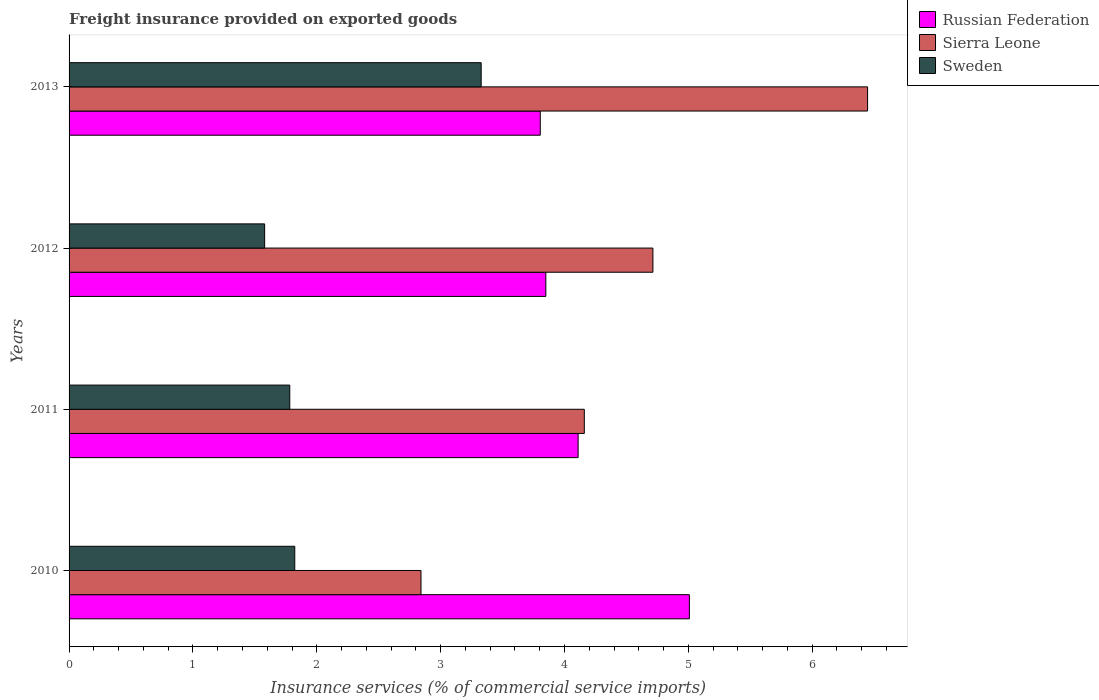How many different coloured bars are there?
Provide a succinct answer. 3. Are the number of bars per tick equal to the number of legend labels?
Provide a succinct answer. Yes. How many bars are there on the 4th tick from the top?
Offer a terse response. 3. In how many cases, is the number of bars for a given year not equal to the number of legend labels?
Ensure brevity in your answer.  0. What is the freight insurance provided on exported goods in Sweden in 2012?
Keep it short and to the point. 1.58. Across all years, what is the maximum freight insurance provided on exported goods in Sweden?
Offer a terse response. 3.33. Across all years, what is the minimum freight insurance provided on exported goods in Russian Federation?
Provide a short and direct response. 3.8. In which year was the freight insurance provided on exported goods in Sierra Leone maximum?
Offer a very short reply. 2013. What is the total freight insurance provided on exported goods in Sweden in the graph?
Provide a succinct answer. 8.51. What is the difference between the freight insurance provided on exported goods in Sweden in 2012 and that in 2013?
Ensure brevity in your answer.  -1.75. What is the difference between the freight insurance provided on exported goods in Russian Federation in 2011 and the freight insurance provided on exported goods in Sweden in 2013?
Make the answer very short. 0.78. What is the average freight insurance provided on exported goods in Sweden per year?
Keep it short and to the point. 2.13. In the year 2012, what is the difference between the freight insurance provided on exported goods in Sierra Leone and freight insurance provided on exported goods in Sweden?
Provide a short and direct response. 3.13. What is the ratio of the freight insurance provided on exported goods in Sweden in 2010 to that in 2013?
Give a very brief answer. 0.55. Is the freight insurance provided on exported goods in Russian Federation in 2010 less than that in 2012?
Keep it short and to the point. No. What is the difference between the highest and the second highest freight insurance provided on exported goods in Sierra Leone?
Give a very brief answer. 1.73. What is the difference between the highest and the lowest freight insurance provided on exported goods in Sierra Leone?
Offer a very short reply. 3.61. Is the sum of the freight insurance provided on exported goods in Russian Federation in 2011 and 2012 greater than the maximum freight insurance provided on exported goods in Sweden across all years?
Provide a short and direct response. Yes. What does the 2nd bar from the top in 2013 represents?
Give a very brief answer. Sierra Leone. What does the 2nd bar from the bottom in 2010 represents?
Your answer should be very brief. Sierra Leone. How many bars are there?
Your answer should be very brief. 12. Are all the bars in the graph horizontal?
Offer a terse response. Yes. Does the graph contain grids?
Offer a terse response. No. What is the title of the graph?
Your response must be concise. Freight insurance provided on exported goods. What is the label or title of the X-axis?
Offer a very short reply. Insurance services (% of commercial service imports). What is the label or title of the Y-axis?
Make the answer very short. Years. What is the Insurance services (% of commercial service imports) in Russian Federation in 2010?
Your answer should be very brief. 5.01. What is the Insurance services (% of commercial service imports) of Sierra Leone in 2010?
Your answer should be very brief. 2.84. What is the Insurance services (% of commercial service imports) in Sweden in 2010?
Your answer should be very brief. 1.82. What is the Insurance services (% of commercial service imports) in Russian Federation in 2011?
Offer a very short reply. 4.11. What is the Insurance services (% of commercial service imports) of Sierra Leone in 2011?
Ensure brevity in your answer.  4.16. What is the Insurance services (% of commercial service imports) in Sweden in 2011?
Provide a succinct answer. 1.78. What is the Insurance services (% of commercial service imports) in Russian Federation in 2012?
Offer a very short reply. 3.85. What is the Insurance services (% of commercial service imports) in Sierra Leone in 2012?
Make the answer very short. 4.71. What is the Insurance services (% of commercial service imports) of Sweden in 2012?
Keep it short and to the point. 1.58. What is the Insurance services (% of commercial service imports) of Russian Federation in 2013?
Your response must be concise. 3.8. What is the Insurance services (% of commercial service imports) in Sierra Leone in 2013?
Ensure brevity in your answer.  6.45. What is the Insurance services (% of commercial service imports) in Sweden in 2013?
Your answer should be compact. 3.33. Across all years, what is the maximum Insurance services (% of commercial service imports) of Russian Federation?
Offer a very short reply. 5.01. Across all years, what is the maximum Insurance services (% of commercial service imports) of Sierra Leone?
Offer a very short reply. 6.45. Across all years, what is the maximum Insurance services (% of commercial service imports) in Sweden?
Give a very brief answer. 3.33. Across all years, what is the minimum Insurance services (% of commercial service imports) of Russian Federation?
Ensure brevity in your answer.  3.8. Across all years, what is the minimum Insurance services (% of commercial service imports) in Sierra Leone?
Your answer should be very brief. 2.84. Across all years, what is the minimum Insurance services (% of commercial service imports) in Sweden?
Make the answer very short. 1.58. What is the total Insurance services (% of commercial service imports) of Russian Federation in the graph?
Provide a succinct answer. 16.77. What is the total Insurance services (% of commercial service imports) in Sierra Leone in the graph?
Make the answer very short. 18.16. What is the total Insurance services (% of commercial service imports) of Sweden in the graph?
Give a very brief answer. 8.51. What is the difference between the Insurance services (% of commercial service imports) in Russian Federation in 2010 and that in 2011?
Keep it short and to the point. 0.9. What is the difference between the Insurance services (% of commercial service imports) of Sierra Leone in 2010 and that in 2011?
Make the answer very short. -1.32. What is the difference between the Insurance services (% of commercial service imports) of Sweden in 2010 and that in 2011?
Give a very brief answer. 0.04. What is the difference between the Insurance services (% of commercial service imports) in Russian Federation in 2010 and that in 2012?
Your answer should be very brief. 1.16. What is the difference between the Insurance services (% of commercial service imports) in Sierra Leone in 2010 and that in 2012?
Your answer should be compact. -1.87. What is the difference between the Insurance services (% of commercial service imports) in Sweden in 2010 and that in 2012?
Give a very brief answer. 0.24. What is the difference between the Insurance services (% of commercial service imports) of Russian Federation in 2010 and that in 2013?
Offer a terse response. 1.2. What is the difference between the Insurance services (% of commercial service imports) in Sierra Leone in 2010 and that in 2013?
Ensure brevity in your answer.  -3.61. What is the difference between the Insurance services (% of commercial service imports) of Sweden in 2010 and that in 2013?
Offer a terse response. -1.51. What is the difference between the Insurance services (% of commercial service imports) of Russian Federation in 2011 and that in 2012?
Provide a short and direct response. 0.26. What is the difference between the Insurance services (% of commercial service imports) in Sierra Leone in 2011 and that in 2012?
Make the answer very short. -0.55. What is the difference between the Insurance services (% of commercial service imports) in Sweden in 2011 and that in 2012?
Your answer should be compact. 0.2. What is the difference between the Insurance services (% of commercial service imports) in Russian Federation in 2011 and that in 2013?
Make the answer very short. 0.31. What is the difference between the Insurance services (% of commercial service imports) in Sierra Leone in 2011 and that in 2013?
Your answer should be compact. -2.29. What is the difference between the Insurance services (% of commercial service imports) of Sweden in 2011 and that in 2013?
Your answer should be very brief. -1.55. What is the difference between the Insurance services (% of commercial service imports) of Russian Federation in 2012 and that in 2013?
Offer a terse response. 0.04. What is the difference between the Insurance services (% of commercial service imports) in Sierra Leone in 2012 and that in 2013?
Ensure brevity in your answer.  -1.73. What is the difference between the Insurance services (% of commercial service imports) of Sweden in 2012 and that in 2013?
Give a very brief answer. -1.75. What is the difference between the Insurance services (% of commercial service imports) in Russian Federation in 2010 and the Insurance services (% of commercial service imports) in Sierra Leone in 2011?
Offer a terse response. 0.85. What is the difference between the Insurance services (% of commercial service imports) of Russian Federation in 2010 and the Insurance services (% of commercial service imports) of Sweden in 2011?
Offer a very short reply. 3.23. What is the difference between the Insurance services (% of commercial service imports) in Sierra Leone in 2010 and the Insurance services (% of commercial service imports) in Sweden in 2011?
Your response must be concise. 1.06. What is the difference between the Insurance services (% of commercial service imports) in Russian Federation in 2010 and the Insurance services (% of commercial service imports) in Sierra Leone in 2012?
Provide a succinct answer. 0.29. What is the difference between the Insurance services (% of commercial service imports) in Russian Federation in 2010 and the Insurance services (% of commercial service imports) in Sweden in 2012?
Keep it short and to the point. 3.43. What is the difference between the Insurance services (% of commercial service imports) of Sierra Leone in 2010 and the Insurance services (% of commercial service imports) of Sweden in 2012?
Your response must be concise. 1.26. What is the difference between the Insurance services (% of commercial service imports) of Russian Federation in 2010 and the Insurance services (% of commercial service imports) of Sierra Leone in 2013?
Offer a very short reply. -1.44. What is the difference between the Insurance services (% of commercial service imports) of Russian Federation in 2010 and the Insurance services (% of commercial service imports) of Sweden in 2013?
Offer a very short reply. 1.68. What is the difference between the Insurance services (% of commercial service imports) of Sierra Leone in 2010 and the Insurance services (% of commercial service imports) of Sweden in 2013?
Ensure brevity in your answer.  -0.49. What is the difference between the Insurance services (% of commercial service imports) of Russian Federation in 2011 and the Insurance services (% of commercial service imports) of Sierra Leone in 2012?
Provide a short and direct response. -0.6. What is the difference between the Insurance services (% of commercial service imports) of Russian Federation in 2011 and the Insurance services (% of commercial service imports) of Sweden in 2012?
Make the answer very short. 2.53. What is the difference between the Insurance services (% of commercial service imports) of Sierra Leone in 2011 and the Insurance services (% of commercial service imports) of Sweden in 2012?
Provide a short and direct response. 2.58. What is the difference between the Insurance services (% of commercial service imports) of Russian Federation in 2011 and the Insurance services (% of commercial service imports) of Sierra Leone in 2013?
Keep it short and to the point. -2.34. What is the difference between the Insurance services (% of commercial service imports) of Russian Federation in 2011 and the Insurance services (% of commercial service imports) of Sweden in 2013?
Provide a short and direct response. 0.78. What is the difference between the Insurance services (% of commercial service imports) of Sierra Leone in 2011 and the Insurance services (% of commercial service imports) of Sweden in 2013?
Provide a short and direct response. 0.83. What is the difference between the Insurance services (% of commercial service imports) of Russian Federation in 2012 and the Insurance services (% of commercial service imports) of Sierra Leone in 2013?
Give a very brief answer. -2.6. What is the difference between the Insurance services (% of commercial service imports) in Russian Federation in 2012 and the Insurance services (% of commercial service imports) in Sweden in 2013?
Your answer should be very brief. 0.52. What is the difference between the Insurance services (% of commercial service imports) in Sierra Leone in 2012 and the Insurance services (% of commercial service imports) in Sweden in 2013?
Offer a very short reply. 1.39. What is the average Insurance services (% of commercial service imports) of Russian Federation per year?
Your response must be concise. 4.19. What is the average Insurance services (% of commercial service imports) of Sierra Leone per year?
Provide a short and direct response. 4.54. What is the average Insurance services (% of commercial service imports) of Sweden per year?
Your answer should be compact. 2.13. In the year 2010, what is the difference between the Insurance services (% of commercial service imports) in Russian Federation and Insurance services (% of commercial service imports) in Sierra Leone?
Provide a succinct answer. 2.17. In the year 2010, what is the difference between the Insurance services (% of commercial service imports) of Russian Federation and Insurance services (% of commercial service imports) of Sweden?
Make the answer very short. 3.19. In the year 2010, what is the difference between the Insurance services (% of commercial service imports) of Sierra Leone and Insurance services (% of commercial service imports) of Sweden?
Give a very brief answer. 1.02. In the year 2011, what is the difference between the Insurance services (% of commercial service imports) of Russian Federation and Insurance services (% of commercial service imports) of Sierra Leone?
Keep it short and to the point. -0.05. In the year 2011, what is the difference between the Insurance services (% of commercial service imports) in Russian Federation and Insurance services (% of commercial service imports) in Sweden?
Offer a terse response. 2.33. In the year 2011, what is the difference between the Insurance services (% of commercial service imports) of Sierra Leone and Insurance services (% of commercial service imports) of Sweden?
Give a very brief answer. 2.38. In the year 2012, what is the difference between the Insurance services (% of commercial service imports) in Russian Federation and Insurance services (% of commercial service imports) in Sierra Leone?
Provide a succinct answer. -0.86. In the year 2012, what is the difference between the Insurance services (% of commercial service imports) in Russian Federation and Insurance services (% of commercial service imports) in Sweden?
Offer a very short reply. 2.27. In the year 2012, what is the difference between the Insurance services (% of commercial service imports) of Sierra Leone and Insurance services (% of commercial service imports) of Sweden?
Offer a terse response. 3.13. In the year 2013, what is the difference between the Insurance services (% of commercial service imports) in Russian Federation and Insurance services (% of commercial service imports) in Sierra Leone?
Offer a terse response. -2.64. In the year 2013, what is the difference between the Insurance services (% of commercial service imports) of Russian Federation and Insurance services (% of commercial service imports) of Sweden?
Your response must be concise. 0.48. In the year 2013, what is the difference between the Insurance services (% of commercial service imports) in Sierra Leone and Insurance services (% of commercial service imports) in Sweden?
Give a very brief answer. 3.12. What is the ratio of the Insurance services (% of commercial service imports) in Russian Federation in 2010 to that in 2011?
Make the answer very short. 1.22. What is the ratio of the Insurance services (% of commercial service imports) in Sierra Leone in 2010 to that in 2011?
Give a very brief answer. 0.68. What is the ratio of the Insurance services (% of commercial service imports) of Sweden in 2010 to that in 2011?
Offer a very short reply. 1.02. What is the ratio of the Insurance services (% of commercial service imports) of Russian Federation in 2010 to that in 2012?
Provide a short and direct response. 1.3. What is the ratio of the Insurance services (% of commercial service imports) in Sierra Leone in 2010 to that in 2012?
Make the answer very short. 0.6. What is the ratio of the Insurance services (% of commercial service imports) of Sweden in 2010 to that in 2012?
Give a very brief answer. 1.15. What is the ratio of the Insurance services (% of commercial service imports) of Russian Federation in 2010 to that in 2013?
Give a very brief answer. 1.32. What is the ratio of the Insurance services (% of commercial service imports) of Sierra Leone in 2010 to that in 2013?
Provide a succinct answer. 0.44. What is the ratio of the Insurance services (% of commercial service imports) of Sweden in 2010 to that in 2013?
Ensure brevity in your answer.  0.55. What is the ratio of the Insurance services (% of commercial service imports) in Russian Federation in 2011 to that in 2012?
Your response must be concise. 1.07. What is the ratio of the Insurance services (% of commercial service imports) of Sierra Leone in 2011 to that in 2012?
Keep it short and to the point. 0.88. What is the ratio of the Insurance services (% of commercial service imports) in Sweden in 2011 to that in 2012?
Provide a short and direct response. 1.13. What is the ratio of the Insurance services (% of commercial service imports) in Russian Federation in 2011 to that in 2013?
Your response must be concise. 1.08. What is the ratio of the Insurance services (% of commercial service imports) in Sierra Leone in 2011 to that in 2013?
Provide a succinct answer. 0.65. What is the ratio of the Insurance services (% of commercial service imports) of Sweden in 2011 to that in 2013?
Your answer should be very brief. 0.54. What is the ratio of the Insurance services (% of commercial service imports) of Russian Federation in 2012 to that in 2013?
Offer a terse response. 1.01. What is the ratio of the Insurance services (% of commercial service imports) in Sierra Leone in 2012 to that in 2013?
Provide a short and direct response. 0.73. What is the ratio of the Insurance services (% of commercial service imports) in Sweden in 2012 to that in 2013?
Make the answer very short. 0.47. What is the difference between the highest and the second highest Insurance services (% of commercial service imports) in Russian Federation?
Make the answer very short. 0.9. What is the difference between the highest and the second highest Insurance services (% of commercial service imports) of Sierra Leone?
Ensure brevity in your answer.  1.73. What is the difference between the highest and the second highest Insurance services (% of commercial service imports) in Sweden?
Provide a succinct answer. 1.51. What is the difference between the highest and the lowest Insurance services (% of commercial service imports) of Russian Federation?
Provide a short and direct response. 1.2. What is the difference between the highest and the lowest Insurance services (% of commercial service imports) of Sierra Leone?
Your answer should be compact. 3.61. What is the difference between the highest and the lowest Insurance services (% of commercial service imports) in Sweden?
Keep it short and to the point. 1.75. 